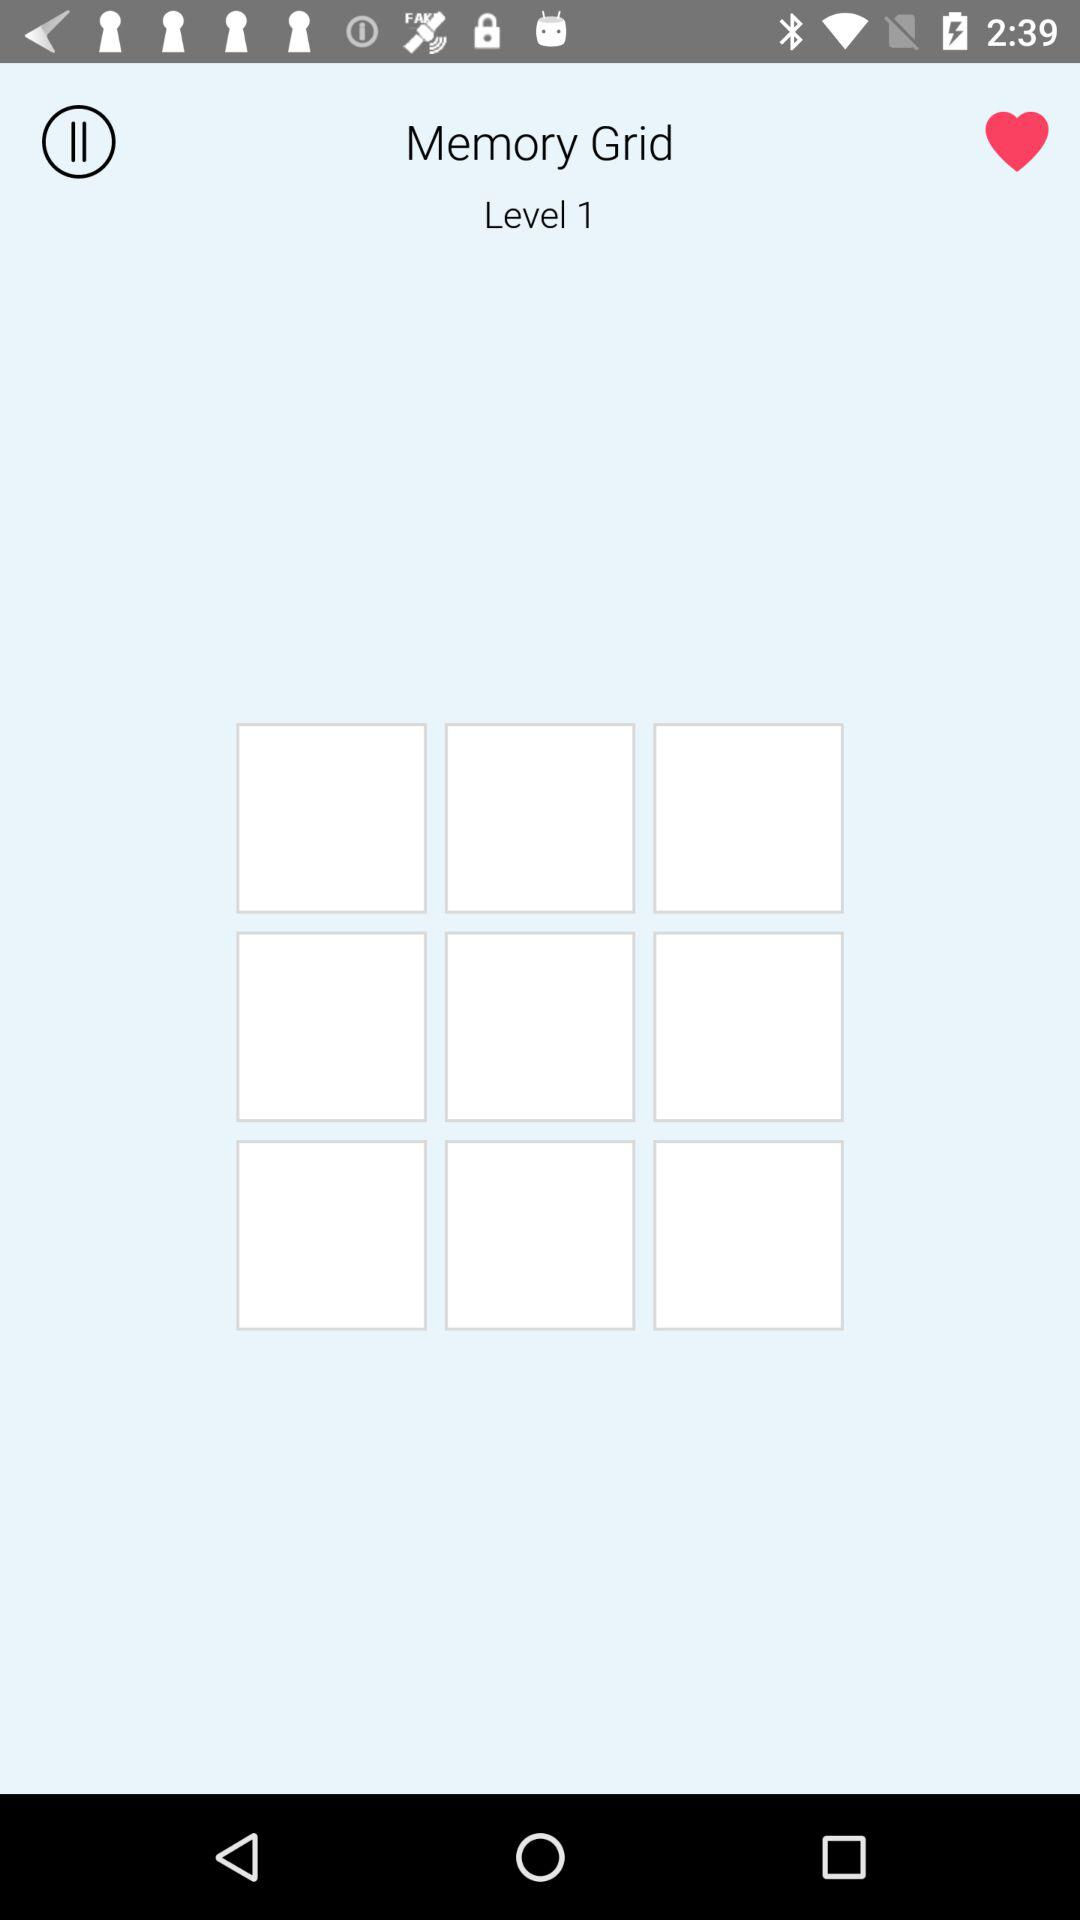Which level am I on? You are on level 1. 